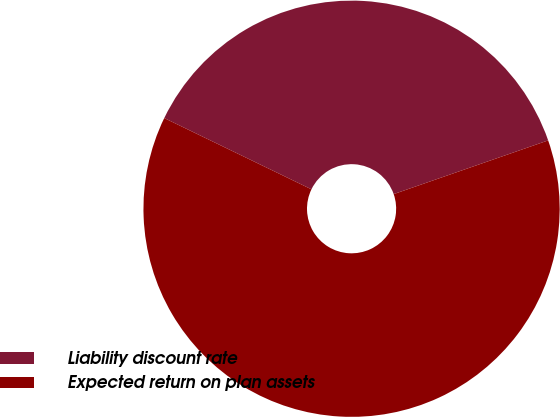<chart> <loc_0><loc_0><loc_500><loc_500><pie_chart><fcel>Liability discount rate<fcel>Expected return on plan assets<nl><fcel>37.5%<fcel>62.5%<nl></chart> 